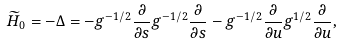<formula> <loc_0><loc_0><loc_500><loc_500>\widetilde { H } _ { 0 } = - \Delta = - g ^ { - 1 / 2 } \frac { \partial } { \partial { s } } g ^ { - 1 / 2 } \frac { \partial } { \partial { s } } - g ^ { - 1 / 2 } \frac { \partial } { \partial { u } } g ^ { 1 / 2 } \frac { \partial } { \partial { u } } ,</formula> 